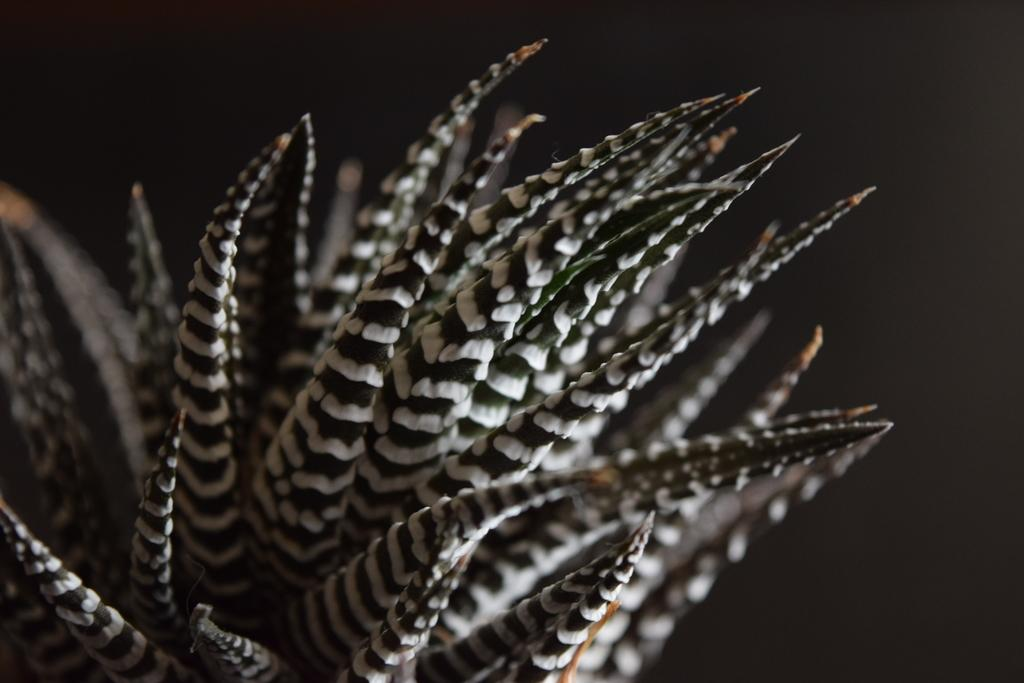What is present in the image? There is a plant in the image. What can be said about the color of the plant? The plant is black and white in color. What type of science experiment is being conducted with the plant in the image? There is no indication of a science experiment in the image; it simply features a black and white plant. Can you see any fire or flames near the plant in the image? No, there is no fire or flames present near the plant in the image. 